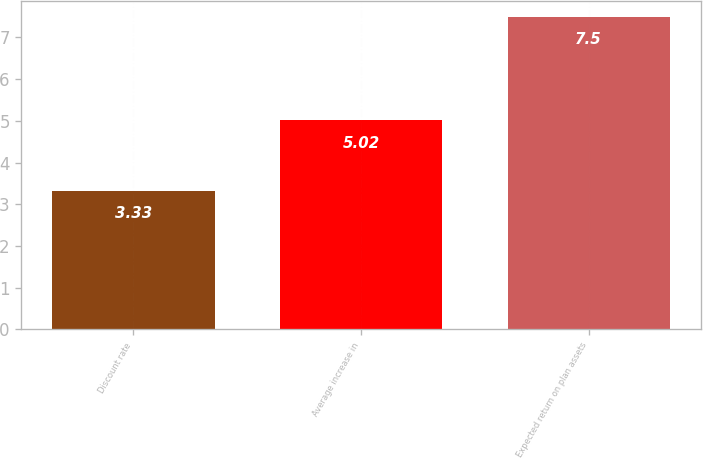Convert chart. <chart><loc_0><loc_0><loc_500><loc_500><bar_chart><fcel>Discount rate<fcel>Average increase in<fcel>Expected return on plan assets<nl><fcel>3.33<fcel>5.02<fcel>7.5<nl></chart> 